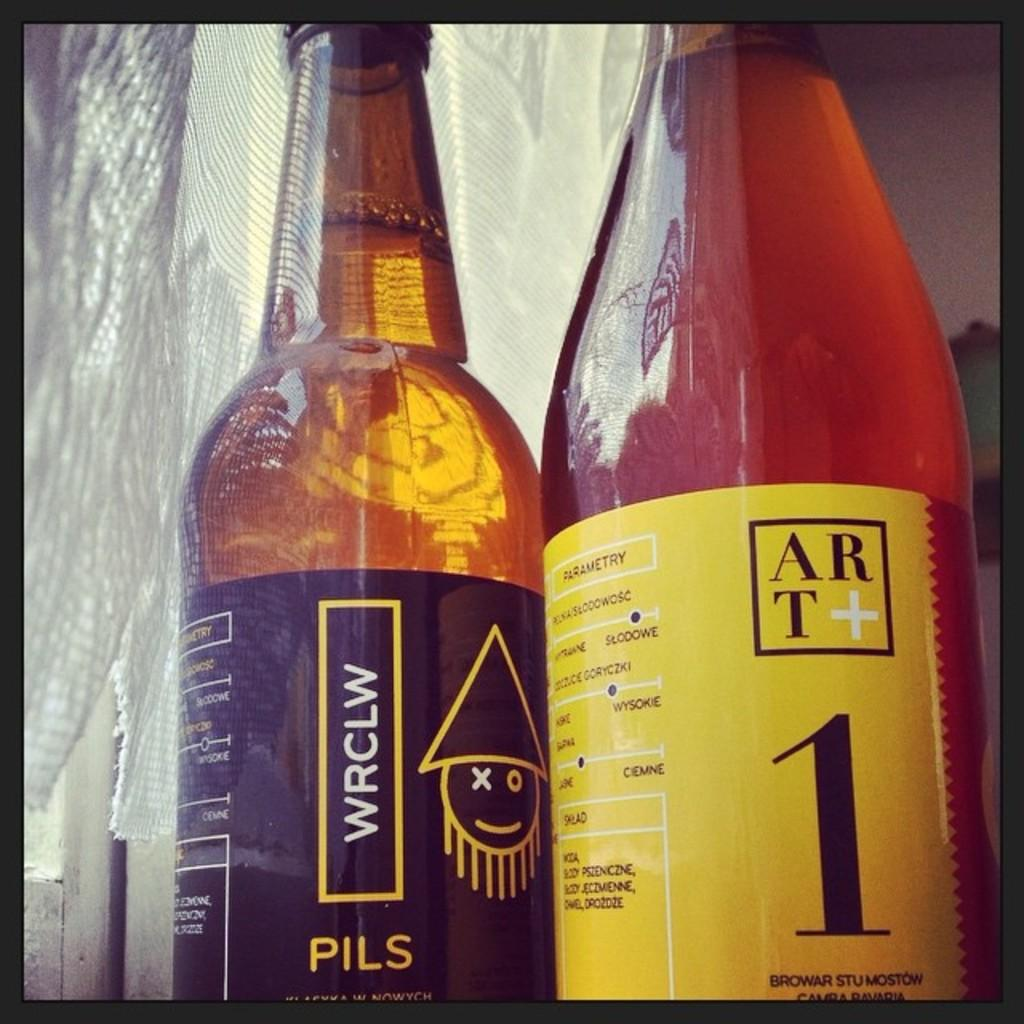<image>
Create a compact narrative representing the image presented. A bottle with a yellow label has Art and 1 on it. 